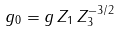Convert formula to latex. <formula><loc_0><loc_0><loc_500><loc_500>g _ { 0 } = g \, Z _ { 1 } \, Z _ { 3 } ^ { - 3 / 2 }</formula> 